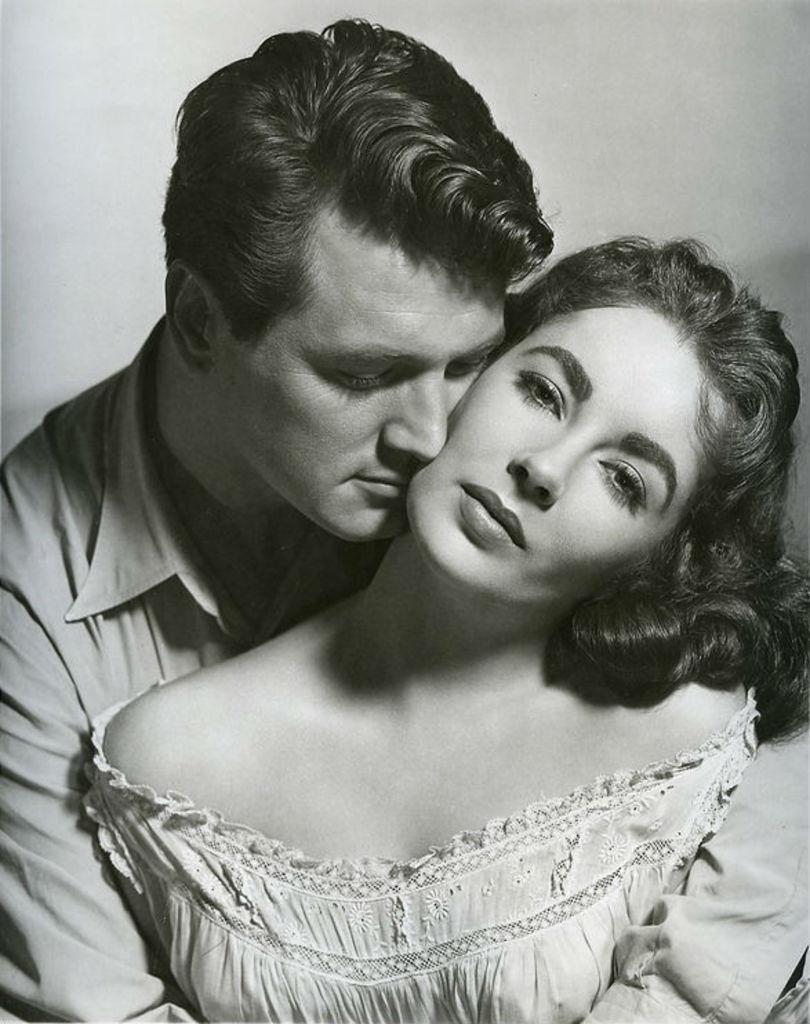Could you give a brief overview of what you see in this image? In this picture we can see a man and woman and it is a black and white photography. 